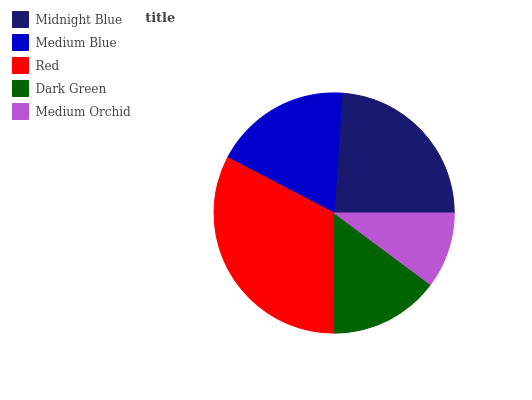Is Medium Orchid the minimum?
Answer yes or no. Yes. Is Red the maximum?
Answer yes or no. Yes. Is Medium Blue the minimum?
Answer yes or no. No. Is Medium Blue the maximum?
Answer yes or no. No. Is Midnight Blue greater than Medium Blue?
Answer yes or no. Yes. Is Medium Blue less than Midnight Blue?
Answer yes or no. Yes. Is Medium Blue greater than Midnight Blue?
Answer yes or no. No. Is Midnight Blue less than Medium Blue?
Answer yes or no. No. Is Medium Blue the high median?
Answer yes or no. Yes. Is Medium Blue the low median?
Answer yes or no. Yes. Is Midnight Blue the high median?
Answer yes or no. No. Is Dark Green the low median?
Answer yes or no. No. 